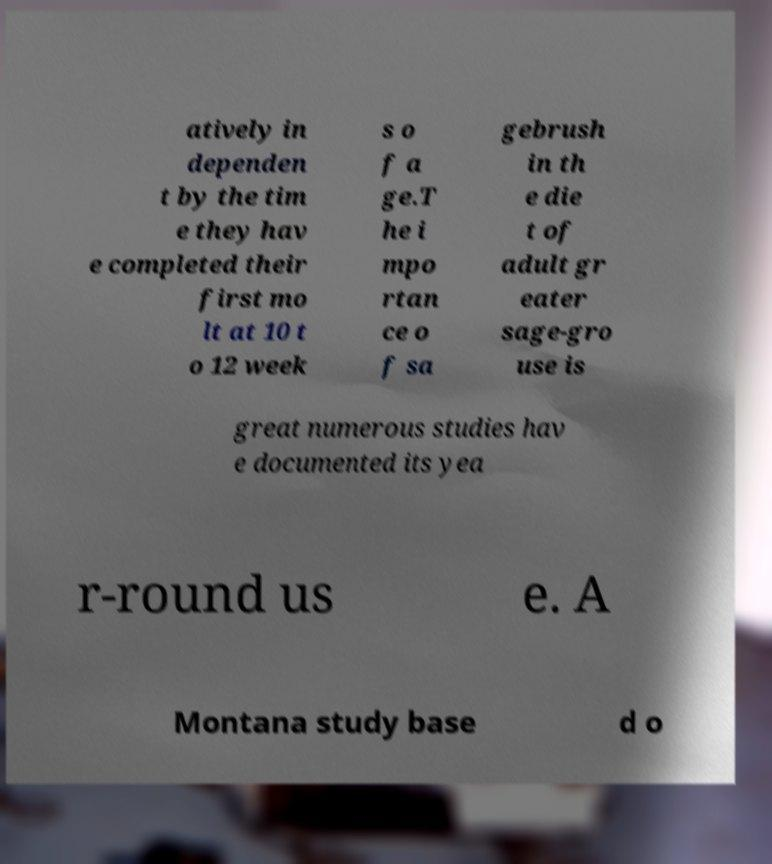Can you accurately transcribe the text from the provided image for me? atively in dependen t by the tim e they hav e completed their first mo lt at 10 t o 12 week s o f a ge.T he i mpo rtan ce o f sa gebrush in th e die t of adult gr eater sage-gro use is great numerous studies hav e documented its yea r-round us e. A Montana study base d o 